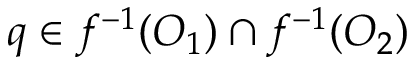<formula> <loc_0><loc_0><loc_500><loc_500>q \in f ^ { - 1 } ( O _ { 1 } ) \cap f ^ { - 1 } ( O _ { 2 } )</formula> 